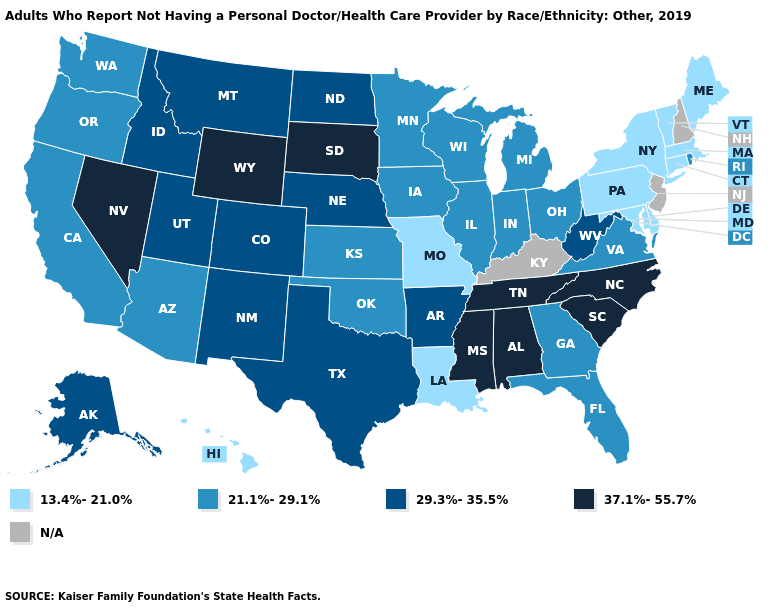Among the states that border Oregon , which have the highest value?
Keep it brief. Nevada. Among the states that border Maryland , does Virginia have the lowest value?
Concise answer only. No. What is the value of Louisiana?
Be succinct. 13.4%-21.0%. Among the states that border North Carolina , does South Carolina have the lowest value?
Answer briefly. No. Among the states that border Georgia , does Florida have the lowest value?
Be succinct. Yes. Name the states that have a value in the range 13.4%-21.0%?
Short answer required. Connecticut, Delaware, Hawaii, Louisiana, Maine, Maryland, Massachusetts, Missouri, New York, Pennsylvania, Vermont. What is the lowest value in the West?
Answer briefly. 13.4%-21.0%. What is the lowest value in the USA?
Concise answer only. 13.4%-21.0%. Among the states that border West Virginia , which have the lowest value?
Give a very brief answer. Maryland, Pennsylvania. What is the value of Oklahoma?
Short answer required. 21.1%-29.1%. What is the lowest value in the South?
Write a very short answer. 13.4%-21.0%. Name the states that have a value in the range 29.3%-35.5%?
Answer briefly. Alaska, Arkansas, Colorado, Idaho, Montana, Nebraska, New Mexico, North Dakota, Texas, Utah, West Virginia. 